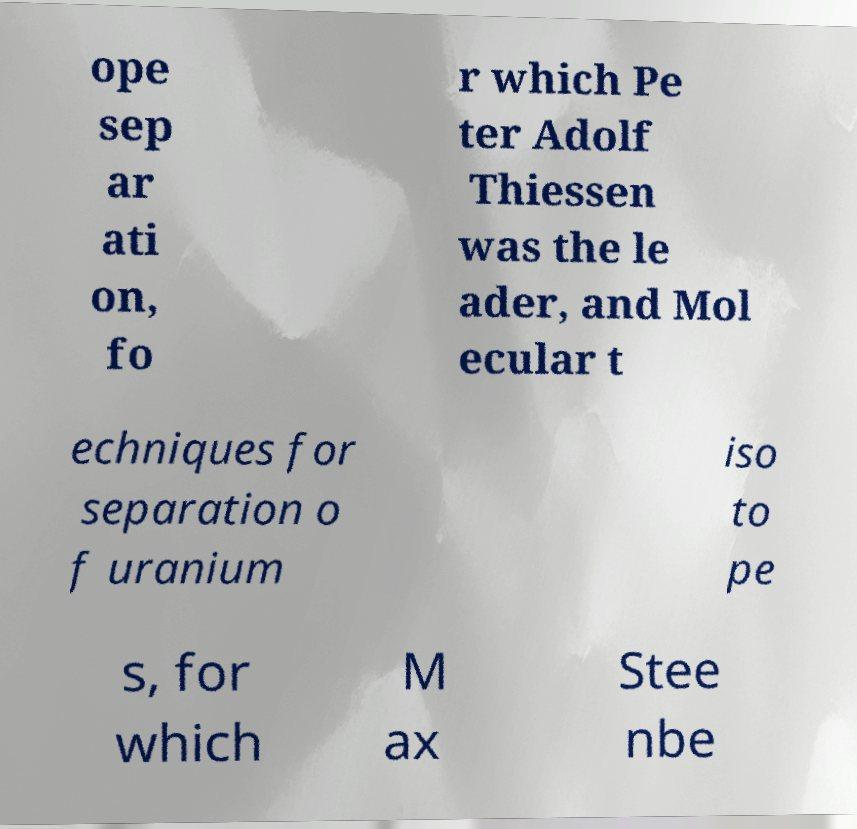Could you extract and type out the text from this image? ope sep ar ati on, fo r which Pe ter Adolf Thiessen was the le ader, and Mol ecular t echniques for separation o f uranium iso to pe s, for which M ax Stee nbe 